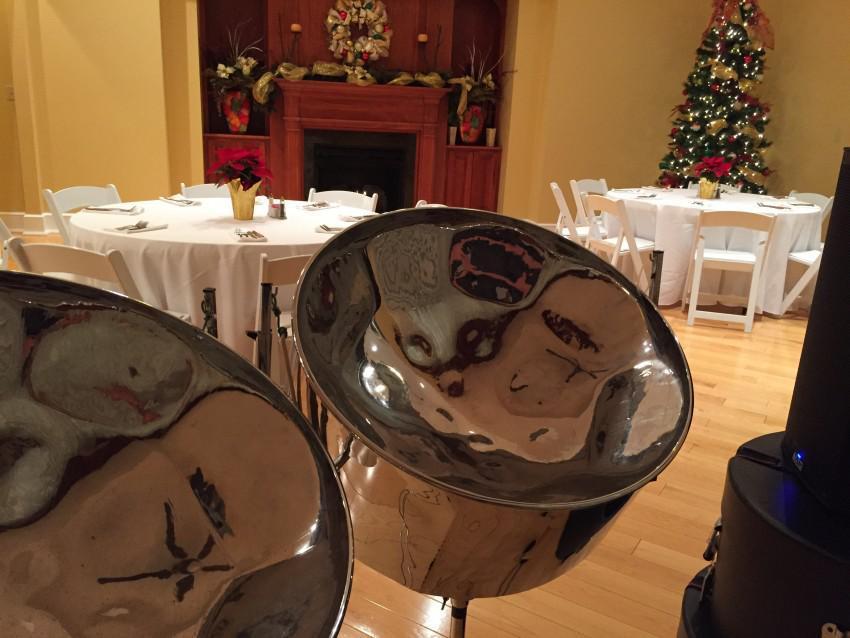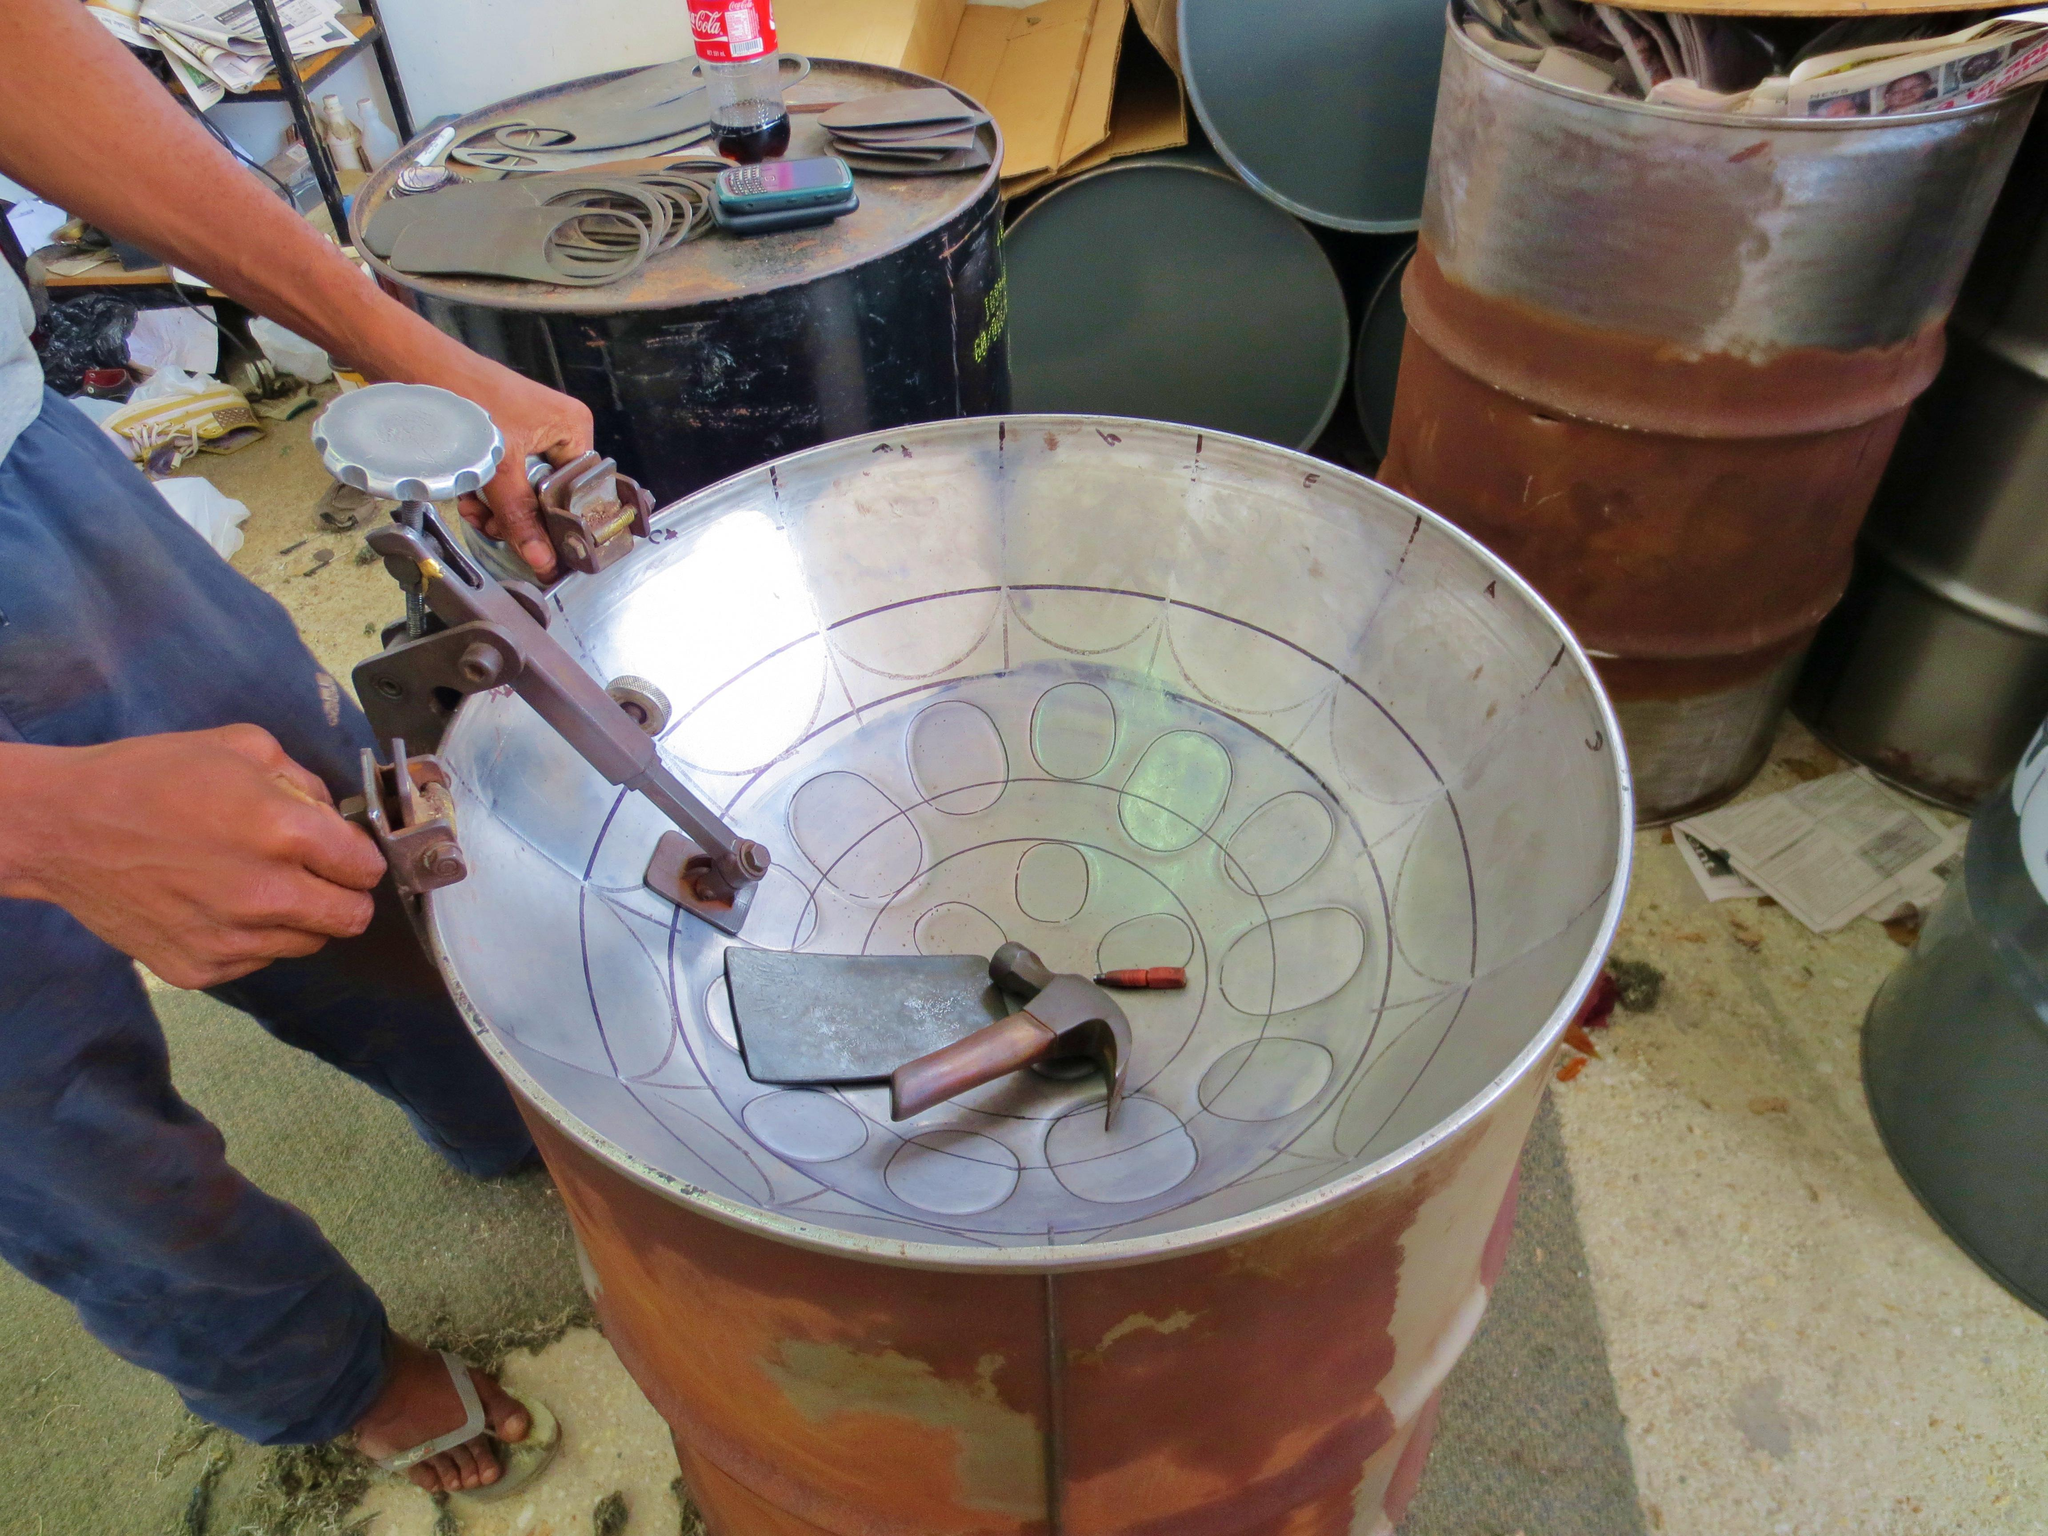The first image is the image on the left, the second image is the image on the right. Given the left and right images, does the statement "In at least one image there is a total of two drums and one man playing them." hold true? Answer yes or no. No. The first image is the image on the left, the second image is the image on the right. Given the left and right images, does the statement "At least one steel drum has drum sticks laying on top." hold true? Answer yes or no. No. 